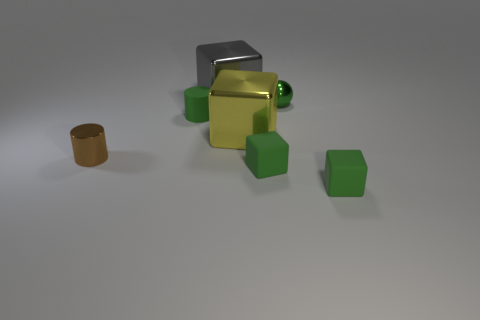Is there a object behind the tiny shiny thing to the right of the yellow shiny object?
Your response must be concise. Yes. Does the gray shiny object have the same shape as the tiny green rubber object that is on the left side of the big gray metal object?
Offer a very short reply. No. What number of other objects are the same size as the brown thing?
Ensure brevity in your answer.  4. What number of yellow things are either small rubber cubes or big blocks?
Provide a succinct answer. 1. How many green rubber things are behind the yellow object and in front of the brown thing?
Make the answer very short. 0. What material is the cylinder that is to the left of the tiny green rubber thing behind the big block in front of the small green rubber cylinder made of?
Give a very brief answer. Metal. How many large cyan blocks are the same material as the big gray cube?
Give a very brief answer. 0. There is a metallic object that is the same color as the rubber cylinder; what is its shape?
Offer a terse response. Sphere. What shape is the yellow shiny object that is the same size as the gray metallic block?
Your response must be concise. Cube. There is a ball that is the same color as the tiny rubber cylinder; what material is it?
Give a very brief answer. Metal. 